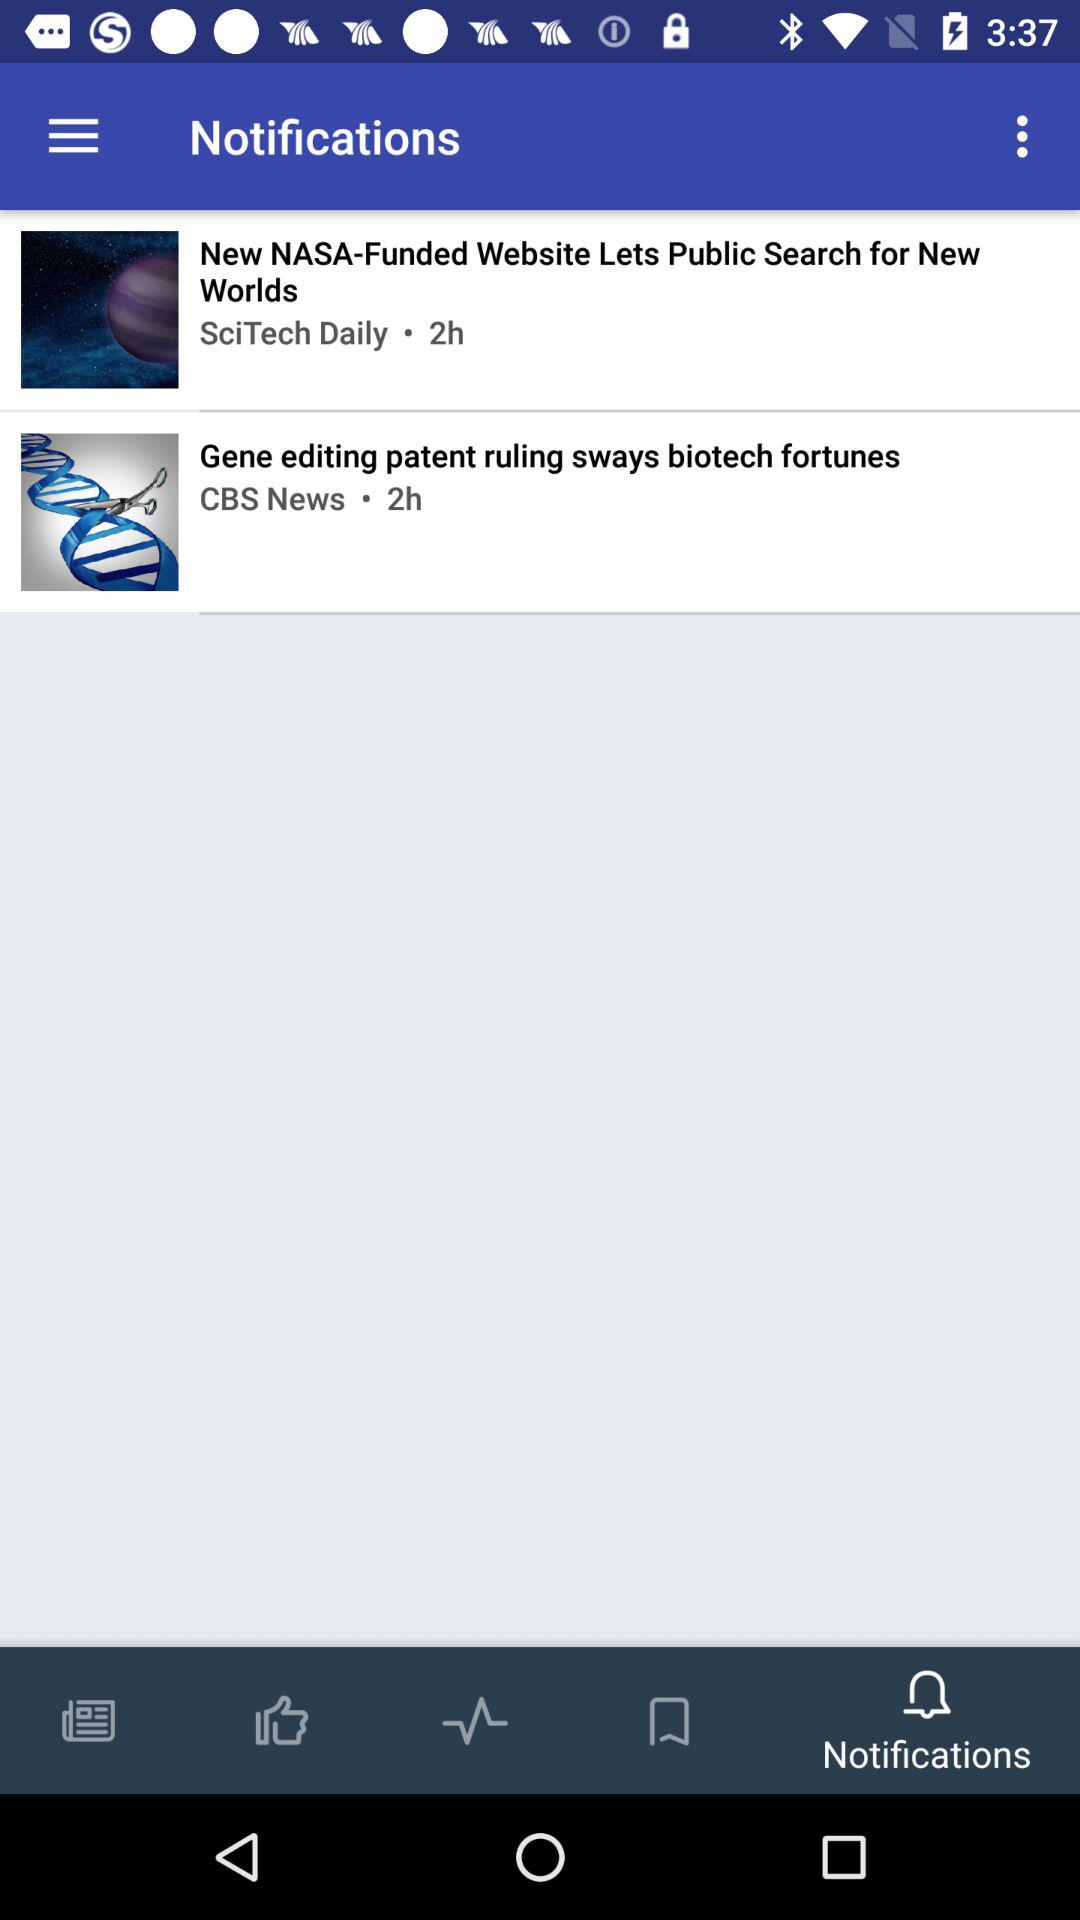Which tab is selected? The selected tab is "Notifications". 